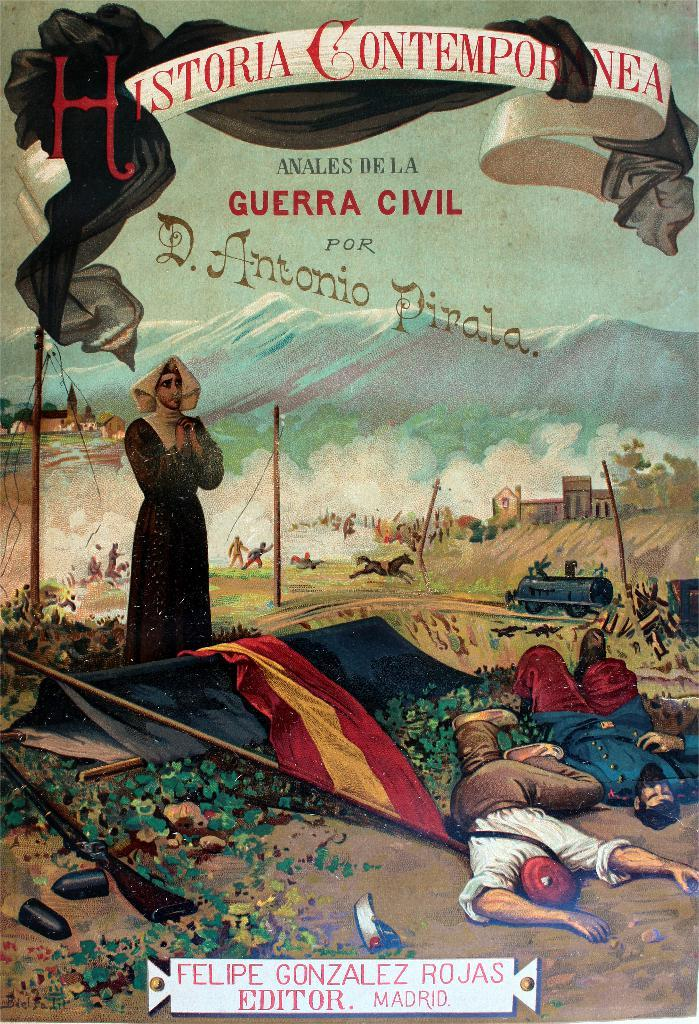What is the main subject of the poster in the image? The poster contains images of persons, animals, trains, mountains, and water, as well as other objects. Can you describe the types of images on the poster? The poster contains images of persons, animals, trains, mountains, and water, as well as other objects. Is there any text on the poster? Yes, there is text on the poster. What type of locket can be seen hanging from the train in the image? There is no locket present in the image, and the train is not depicted as having any accessories. 